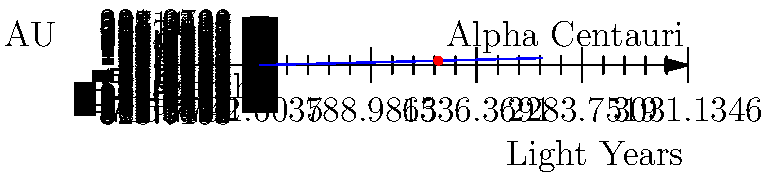In the spirit of understanding the vastness of our universe and the connections between celestial bodies, consider the distance between Earth and its nearest stellar neighbor, Alpha Centauri. If one light-year is approximately 63,241 astronomical units (AU), how far is Alpha Centauri from Earth in astronomical units? Let's approach this step-by-step:

1. We know that Alpha Centauri is the nearest star system to Earth, at a distance of approximately 4.37 light-years.

2. We're given that 1 light-year ≈ 63,241 AU

3. To find the distance in AU, we need to multiply the distance in light-years by the number of AU in one light-year:

   $$ \text{Distance in AU} = \text{Distance in light-years} \times \text{AU per light-year} $$

4. Plugging in our values:

   $$ \text{Distance in AU} = 4.37 \times 63,241 $$

5. Calculating:

   $$ \text{Distance in AU} = 276,363.17 $$

6. Rounding to a reasonable number of significant figures:

   $$ \text{Distance in AU} ≈ 276,000 $$

This calculation illustrates the vast distances in space and how we use different units (light-years and AU) to describe them in a way that's meaningful for different scales.
Answer: Approximately 276,000 AU 